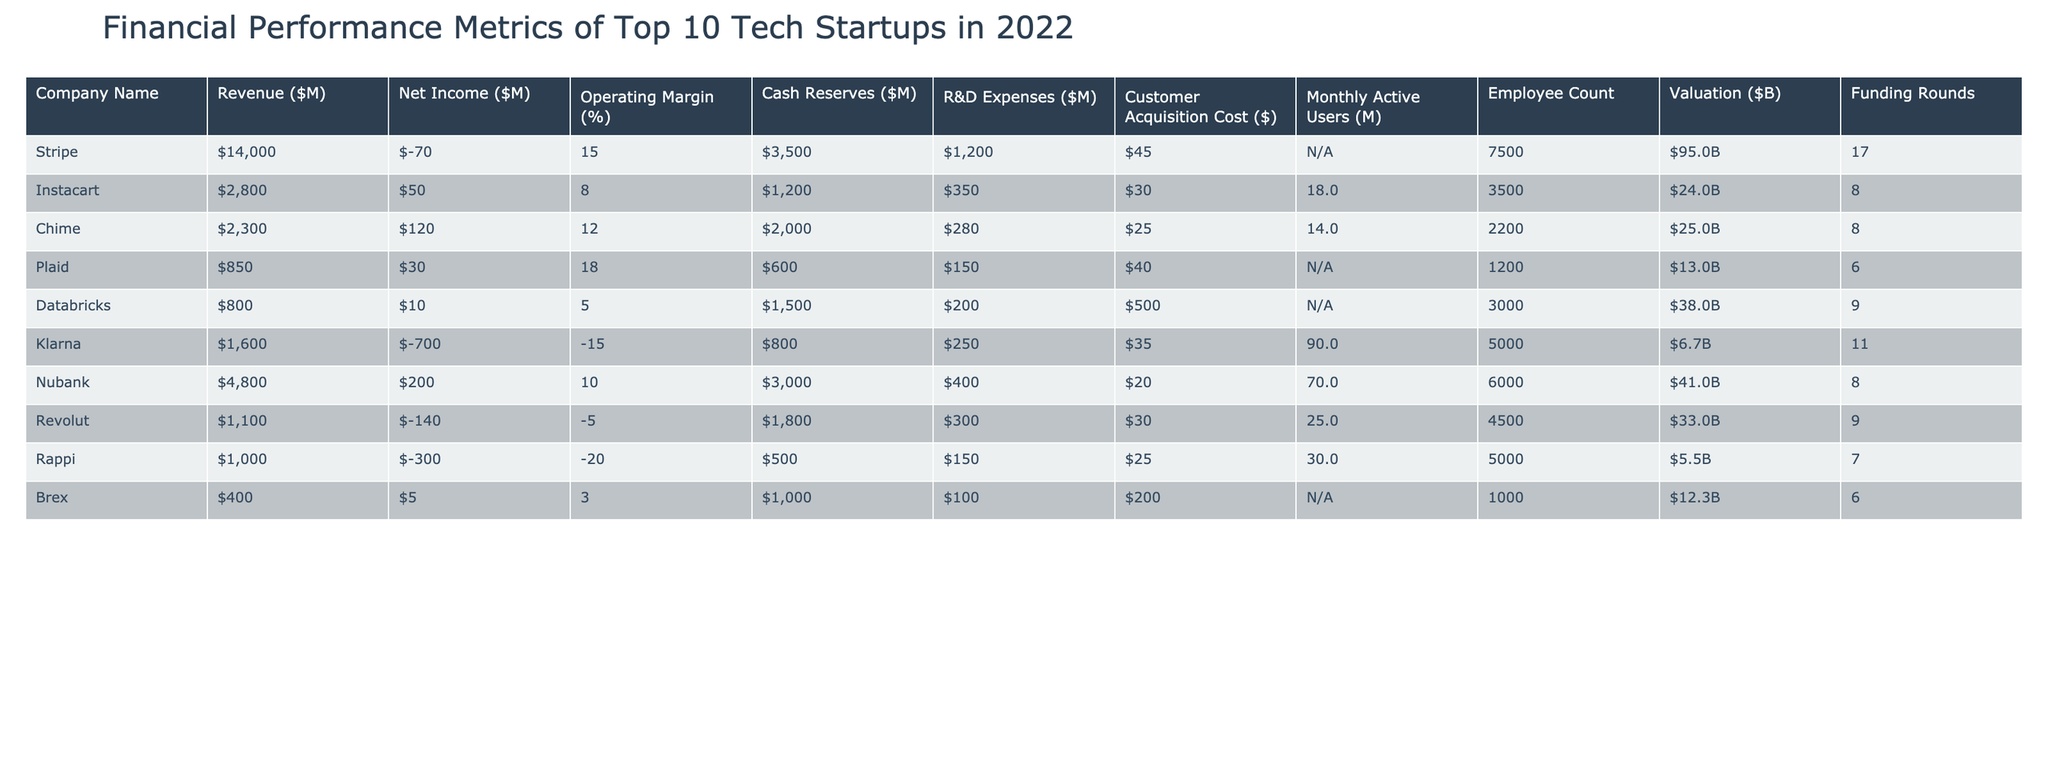What is the revenue of Stripe? The revenue of Stripe is listed in the table under the "Revenue ($M)" column, which shows a value of $14,000 million.
Answer: $14,000 million Which company has the highest net income? The net income values are compared in the "Net Income ($M)" column. The highest value is $200 million for Nubank.
Answer: Nubank What is the operating margin of Klarna? The operating margin for Klarna can be found in the "Operating Margin (%)" column, which shows a value of -15%.
Answer: -15% What is the total R&D expense for all companies combined? To find the total R&D expenses, sum the R&D expenses: 1200 + 350 + 280 + 150 + 200 + 250 + 400 + 300 + 150 + 100 = 2,880 million.
Answer: $2,880 million Which company had the lowest valuation? The "Valuation ($B)" column shows the values, and the lowest is $5.5 billion for Rappi.
Answer: Rappi Does Databricks have a net income greater than zero? The net income for Databricks is $10 million, which is greater than zero, so the answer is yes.
Answer: Yes What is the average customer acquisition cost among these companies? To calculate the average, sum the customer acquisition costs: 45 + 30 + 25 + 40 + 500 + 35 + 20 + 30 + 25 + 200 = 30. Adding these gives 2,045; then divide by 10 to find the average: 2,045 / 10 = 204.5.
Answer: $204.5 Which company has more monthly active users, Chime or Revolut? Chime has 14 million monthly active users, while Revolut has 25 million. Comparing these values shows Revolut has more users.
Answer: Revolut What percentage of revenue does Nubank spend on R&D? Nubank's R&D expense is $400 million, and its revenue is $4,800 million. To find the percentage, (400/4800) * 100 = 8.33%.
Answer: 8.33% Is the cash reserve of Instacart higher than the net income? Instacart's cash reserve is $1,200 million, and its net income is $50 million. Since $1,200 million is greater than $50 million, the answer is yes.
Answer: Yes Which company has the lowest operating margin and what is it? The operating margin can be reviewed in the "Operating Margin (%)" column, with Klarna having the lowest margin at -15%.
Answer: -15% 